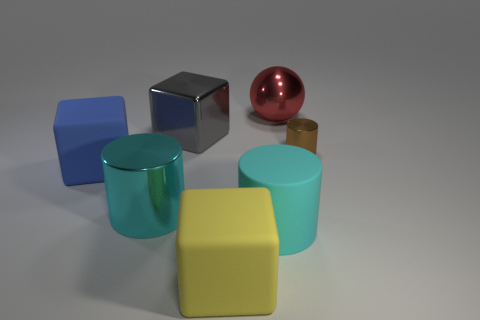Subtract all metallic cylinders. How many cylinders are left? 1 Add 1 large blue matte blocks. How many objects exist? 8 Subtract all brown cylinders. How many cylinders are left? 2 Subtract 1 spheres. How many spheres are left? 0 Subtract all cubes. How many objects are left? 4 Subtract all gray spheres. Subtract all red cylinders. How many spheres are left? 1 Subtract all blue cubes. How many cyan cylinders are left? 2 Subtract all green balls. Subtract all large rubber blocks. How many objects are left? 5 Add 5 tiny metal objects. How many tiny metal objects are left? 6 Add 6 big red metallic things. How many big red metallic things exist? 7 